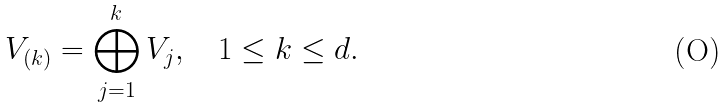<formula> <loc_0><loc_0><loc_500><loc_500>V _ { ( k ) } = \bigoplus _ { j = 1 } ^ { k } V _ { j } , \quad 1 \leq k \leq d .</formula> 